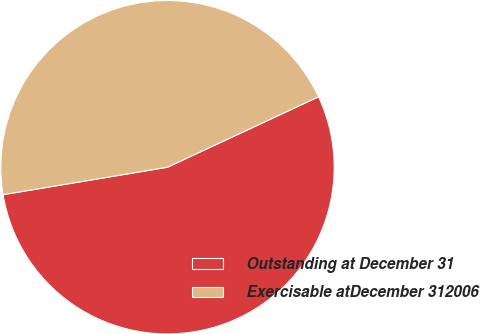Convert chart to OTSL. <chart><loc_0><loc_0><loc_500><loc_500><pie_chart><fcel>Outstanding at December 31<fcel>Exercisable atDecember 312006<nl><fcel>54.31%<fcel>45.69%<nl></chart> 